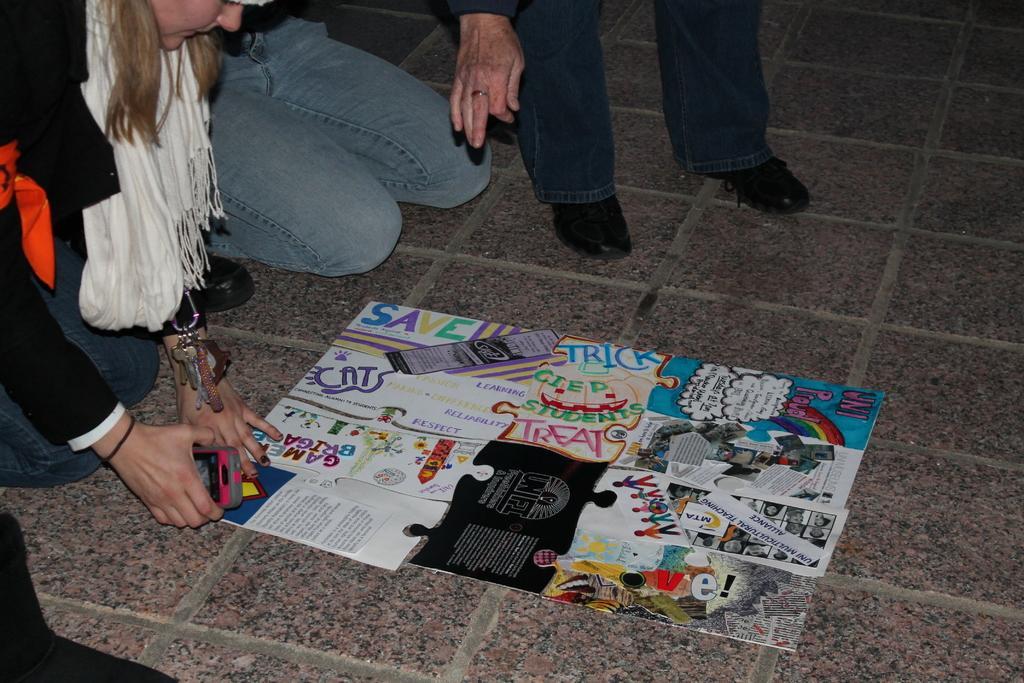Please provide a concise description of this image. In this image three persons are on the floor. Left side a woman wearing white colour scarf is holding a mobile in her hand. Few posters are on the floor. Top of the image there is a person standing on the floor. He is wearing shoes. 